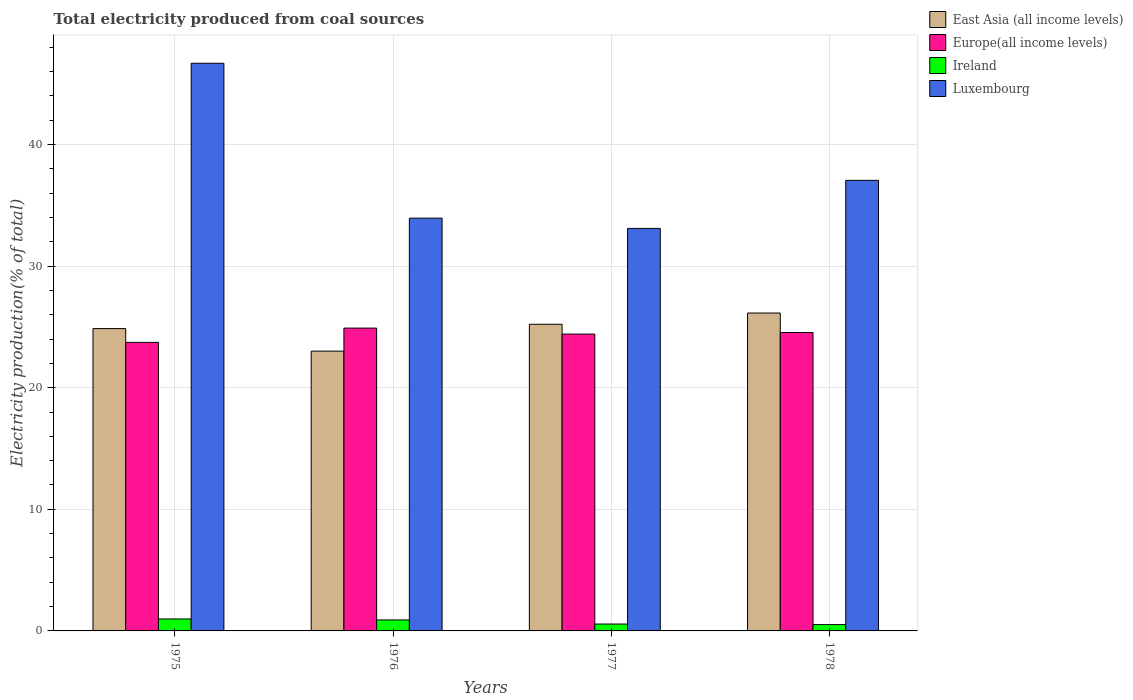Are the number of bars per tick equal to the number of legend labels?
Provide a short and direct response. Yes. Are the number of bars on each tick of the X-axis equal?
Your answer should be compact. Yes. How many bars are there on the 3rd tick from the left?
Offer a very short reply. 4. What is the label of the 4th group of bars from the left?
Give a very brief answer. 1978. In how many cases, is the number of bars for a given year not equal to the number of legend labels?
Your response must be concise. 0. What is the total electricity produced in Ireland in 1978?
Make the answer very short. 0.52. Across all years, what is the maximum total electricity produced in Luxembourg?
Give a very brief answer. 46.68. Across all years, what is the minimum total electricity produced in Europe(all income levels)?
Make the answer very short. 23.73. In which year was the total electricity produced in East Asia (all income levels) maximum?
Make the answer very short. 1978. In which year was the total electricity produced in Europe(all income levels) minimum?
Offer a very short reply. 1975. What is the total total electricity produced in East Asia (all income levels) in the graph?
Offer a very short reply. 99.23. What is the difference between the total electricity produced in East Asia (all income levels) in 1977 and that in 1978?
Offer a terse response. -0.92. What is the difference between the total electricity produced in Europe(all income levels) in 1975 and the total electricity produced in Ireland in 1978?
Make the answer very short. 23.21. What is the average total electricity produced in Europe(all income levels) per year?
Make the answer very short. 24.39. In the year 1977, what is the difference between the total electricity produced in East Asia (all income levels) and total electricity produced in Europe(all income levels)?
Give a very brief answer. 0.81. What is the ratio of the total electricity produced in Europe(all income levels) in 1975 to that in 1977?
Offer a very short reply. 0.97. Is the total electricity produced in Luxembourg in 1975 less than that in 1976?
Your response must be concise. No. Is the difference between the total electricity produced in East Asia (all income levels) in 1977 and 1978 greater than the difference between the total electricity produced in Europe(all income levels) in 1977 and 1978?
Ensure brevity in your answer.  No. What is the difference between the highest and the second highest total electricity produced in Luxembourg?
Your response must be concise. 9.63. What is the difference between the highest and the lowest total electricity produced in Ireland?
Your response must be concise. 0.47. Is the sum of the total electricity produced in Luxembourg in 1976 and 1978 greater than the maximum total electricity produced in East Asia (all income levels) across all years?
Your response must be concise. Yes. Is it the case that in every year, the sum of the total electricity produced in Europe(all income levels) and total electricity produced in Luxembourg is greater than the sum of total electricity produced in Ireland and total electricity produced in East Asia (all income levels)?
Provide a succinct answer. Yes. What does the 1st bar from the left in 1977 represents?
Give a very brief answer. East Asia (all income levels). What does the 3rd bar from the right in 1976 represents?
Make the answer very short. Europe(all income levels). Is it the case that in every year, the sum of the total electricity produced in Luxembourg and total electricity produced in Europe(all income levels) is greater than the total electricity produced in East Asia (all income levels)?
Your answer should be very brief. Yes. Are the values on the major ticks of Y-axis written in scientific E-notation?
Your response must be concise. No. How many legend labels are there?
Make the answer very short. 4. How are the legend labels stacked?
Offer a terse response. Vertical. What is the title of the graph?
Keep it short and to the point. Total electricity produced from coal sources. What is the label or title of the X-axis?
Offer a terse response. Years. What is the Electricity production(% of total) in East Asia (all income levels) in 1975?
Make the answer very short. 24.86. What is the Electricity production(% of total) of Europe(all income levels) in 1975?
Your response must be concise. 23.73. What is the Electricity production(% of total) in Ireland in 1975?
Offer a very short reply. 0.98. What is the Electricity production(% of total) in Luxembourg in 1975?
Your response must be concise. 46.68. What is the Electricity production(% of total) in East Asia (all income levels) in 1976?
Provide a succinct answer. 23.01. What is the Electricity production(% of total) in Europe(all income levels) in 1976?
Keep it short and to the point. 24.9. What is the Electricity production(% of total) of Ireland in 1976?
Provide a short and direct response. 0.9. What is the Electricity production(% of total) in Luxembourg in 1976?
Your response must be concise. 33.94. What is the Electricity production(% of total) in East Asia (all income levels) in 1977?
Ensure brevity in your answer.  25.22. What is the Electricity production(% of total) in Europe(all income levels) in 1977?
Provide a succinct answer. 24.41. What is the Electricity production(% of total) in Ireland in 1977?
Your answer should be compact. 0.57. What is the Electricity production(% of total) of Luxembourg in 1977?
Make the answer very short. 33.1. What is the Electricity production(% of total) of East Asia (all income levels) in 1978?
Your response must be concise. 26.14. What is the Electricity production(% of total) in Europe(all income levels) in 1978?
Ensure brevity in your answer.  24.54. What is the Electricity production(% of total) in Ireland in 1978?
Offer a very short reply. 0.52. What is the Electricity production(% of total) in Luxembourg in 1978?
Offer a very short reply. 37.05. Across all years, what is the maximum Electricity production(% of total) in East Asia (all income levels)?
Keep it short and to the point. 26.14. Across all years, what is the maximum Electricity production(% of total) of Europe(all income levels)?
Your answer should be very brief. 24.9. Across all years, what is the maximum Electricity production(% of total) of Ireland?
Your answer should be compact. 0.98. Across all years, what is the maximum Electricity production(% of total) in Luxembourg?
Provide a short and direct response. 46.68. Across all years, what is the minimum Electricity production(% of total) in East Asia (all income levels)?
Provide a succinct answer. 23.01. Across all years, what is the minimum Electricity production(% of total) of Europe(all income levels)?
Your answer should be compact. 23.73. Across all years, what is the minimum Electricity production(% of total) in Ireland?
Your answer should be compact. 0.52. Across all years, what is the minimum Electricity production(% of total) in Luxembourg?
Provide a short and direct response. 33.1. What is the total Electricity production(% of total) of East Asia (all income levels) in the graph?
Offer a terse response. 99.23. What is the total Electricity production(% of total) of Europe(all income levels) in the graph?
Provide a short and direct response. 97.57. What is the total Electricity production(% of total) in Ireland in the graph?
Give a very brief answer. 2.97. What is the total Electricity production(% of total) of Luxembourg in the graph?
Your answer should be compact. 150.77. What is the difference between the Electricity production(% of total) in East Asia (all income levels) in 1975 and that in 1976?
Offer a very short reply. 1.85. What is the difference between the Electricity production(% of total) of Europe(all income levels) in 1975 and that in 1976?
Offer a terse response. -1.18. What is the difference between the Electricity production(% of total) of Ireland in 1975 and that in 1976?
Provide a succinct answer. 0.08. What is the difference between the Electricity production(% of total) of Luxembourg in 1975 and that in 1976?
Your answer should be very brief. 12.74. What is the difference between the Electricity production(% of total) in East Asia (all income levels) in 1975 and that in 1977?
Provide a succinct answer. -0.36. What is the difference between the Electricity production(% of total) in Europe(all income levels) in 1975 and that in 1977?
Ensure brevity in your answer.  -0.68. What is the difference between the Electricity production(% of total) in Ireland in 1975 and that in 1977?
Keep it short and to the point. 0.42. What is the difference between the Electricity production(% of total) of Luxembourg in 1975 and that in 1977?
Provide a succinct answer. 13.58. What is the difference between the Electricity production(% of total) in East Asia (all income levels) in 1975 and that in 1978?
Your answer should be compact. -1.28. What is the difference between the Electricity production(% of total) of Europe(all income levels) in 1975 and that in 1978?
Ensure brevity in your answer.  -0.81. What is the difference between the Electricity production(% of total) of Ireland in 1975 and that in 1978?
Provide a succinct answer. 0.47. What is the difference between the Electricity production(% of total) of Luxembourg in 1975 and that in 1978?
Your answer should be compact. 9.63. What is the difference between the Electricity production(% of total) of East Asia (all income levels) in 1976 and that in 1977?
Give a very brief answer. -2.21. What is the difference between the Electricity production(% of total) of Europe(all income levels) in 1976 and that in 1977?
Offer a very short reply. 0.49. What is the difference between the Electricity production(% of total) in Ireland in 1976 and that in 1977?
Provide a succinct answer. 0.34. What is the difference between the Electricity production(% of total) in Luxembourg in 1976 and that in 1977?
Your answer should be very brief. 0.84. What is the difference between the Electricity production(% of total) of East Asia (all income levels) in 1976 and that in 1978?
Your answer should be compact. -3.13. What is the difference between the Electricity production(% of total) of Europe(all income levels) in 1976 and that in 1978?
Offer a terse response. 0.37. What is the difference between the Electricity production(% of total) in Ireland in 1976 and that in 1978?
Your answer should be compact. 0.38. What is the difference between the Electricity production(% of total) of Luxembourg in 1976 and that in 1978?
Provide a short and direct response. -3.11. What is the difference between the Electricity production(% of total) in East Asia (all income levels) in 1977 and that in 1978?
Your answer should be very brief. -0.92. What is the difference between the Electricity production(% of total) of Europe(all income levels) in 1977 and that in 1978?
Your response must be concise. -0.13. What is the difference between the Electricity production(% of total) in Ireland in 1977 and that in 1978?
Your response must be concise. 0.05. What is the difference between the Electricity production(% of total) of Luxembourg in 1977 and that in 1978?
Offer a terse response. -3.95. What is the difference between the Electricity production(% of total) in East Asia (all income levels) in 1975 and the Electricity production(% of total) in Europe(all income levels) in 1976?
Offer a very short reply. -0.04. What is the difference between the Electricity production(% of total) in East Asia (all income levels) in 1975 and the Electricity production(% of total) in Ireland in 1976?
Your response must be concise. 23.96. What is the difference between the Electricity production(% of total) in East Asia (all income levels) in 1975 and the Electricity production(% of total) in Luxembourg in 1976?
Your response must be concise. -9.08. What is the difference between the Electricity production(% of total) in Europe(all income levels) in 1975 and the Electricity production(% of total) in Ireland in 1976?
Provide a succinct answer. 22.82. What is the difference between the Electricity production(% of total) of Europe(all income levels) in 1975 and the Electricity production(% of total) of Luxembourg in 1976?
Provide a succinct answer. -10.22. What is the difference between the Electricity production(% of total) in Ireland in 1975 and the Electricity production(% of total) in Luxembourg in 1976?
Offer a terse response. -32.96. What is the difference between the Electricity production(% of total) of East Asia (all income levels) in 1975 and the Electricity production(% of total) of Europe(all income levels) in 1977?
Give a very brief answer. 0.45. What is the difference between the Electricity production(% of total) in East Asia (all income levels) in 1975 and the Electricity production(% of total) in Ireland in 1977?
Offer a terse response. 24.3. What is the difference between the Electricity production(% of total) in East Asia (all income levels) in 1975 and the Electricity production(% of total) in Luxembourg in 1977?
Offer a terse response. -8.24. What is the difference between the Electricity production(% of total) of Europe(all income levels) in 1975 and the Electricity production(% of total) of Ireland in 1977?
Ensure brevity in your answer.  23.16. What is the difference between the Electricity production(% of total) of Europe(all income levels) in 1975 and the Electricity production(% of total) of Luxembourg in 1977?
Your answer should be very brief. -9.37. What is the difference between the Electricity production(% of total) of Ireland in 1975 and the Electricity production(% of total) of Luxembourg in 1977?
Your answer should be very brief. -32.11. What is the difference between the Electricity production(% of total) in East Asia (all income levels) in 1975 and the Electricity production(% of total) in Europe(all income levels) in 1978?
Make the answer very short. 0.33. What is the difference between the Electricity production(% of total) in East Asia (all income levels) in 1975 and the Electricity production(% of total) in Ireland in 1978?
Your response must be concise. 24.34. What is the difference between the Electricity production(% of total) of East Asia (all income levels) in 1975 and the Electricity production(% of total) of Luxembourg in 1978?
Offer a terse response. -12.19. What is the difference between the Electricity production(% of total) of Europe(all income levels) in 1975 and the Electricity production(% of total) of Ireland in 1978?
Keep it short and to the point. 23.21. What is the difference between the Electricity production(% of total) of Europe(all income levels) in 1975 and the Electricity production(% of total) of Luxembourg in 1978?
Provide a succinct answer. -13.32. What is the difference between the Electricity production(% of total) in Ireland in 1975 and the Electricity production(% of total) in Luxembourg in 1978?
Your response must be concise. -36.07. What is the difference between the Electricity production(% of total) of East Asia (all income levels) in 1976 and the Electricity production(% of total) of Europe(all income levels) in 1977?
Keep it short and to the point. -1.4. What is the difference between the Electricity production(% of total) in East Asia (all income levels) in 1976 and the Electricity production(% of total) in Ireland in 1977?
Keep it short and to the point. 22.44. What is the difference between the Electricity production(% of total) in East Asia (all income levels) in 1976 and the Electricity production(% of total) in Luxembourg in 1977?
Keep it short and to the point. -10.09. What is the difference between the Electricity production(% of total) in Europe(all income levels) in 1976 and the Electricity production(% of total) in Ireland in 1977?
Ensure brevity in your answer.  24.34. What is the difference between the Electricity production(% of total) in Europe(all income levels) in 1976 and the Electricity production(% of total) in Luxembourg in 1977?
Make the answer very short. -8.2. What is the difference between the Electricity production(% of total) in Ireland in 1976 and the Electricity production(% of total) in Luxembourg in 1977?
Offer a very short reply. -32.2. What is the difference between the Electricity production(% of total) of East Asia (all income levels) in 1976 and the Electricity production(% of total) of Europe(all income levels) in 1978?
Make the answer very short. -1.53. What is the difference between the Electricity production(% of total) in East Asia (all income levels) in 1976 and the Electricity production(% of total) in Ireland in 1978?
Provide a short and direct response. 22.49. What is the difference between the Electricity production(% of total) of East Asia (all income levels) in 1976 and the Electricity production(% of total) of Luxembourg in 1978?
Your answer should be compact. -14.04. What is the difference between the Electricity production(% of total) in Europe(all income levels) in 1976 and the Electricity production(% of total) in Ireland in 1978?
Keep it short and to the point. 24.38. What is the difference between the Electricity production(% of total) in Europe(all income levels) in 1976 and the Electricity production(% of total) in Luxembourg in 1978?
Ensure brevity in your answer.  -12.15. What is the difference between the Electricity production(% of total) in Ireland in 1976 and the Electricity production(% of total) in Luxembourg in 1978?
Offer a terse response. -36.15. What is the difference between the Electricity production(% of total) of East Asia (all income levels) in 1977 and the Electricity production(% of total) of Europe(all income levels) in 1978?
Offer a terse response. 0.68. What is the difference between the Electricity production(% of total) in East Asia (all income levels) in 1977 and the Electricity production(% of total) in Ireland in 1978?
Ensure brevity in your answer.  24.7. What is the difference between the Electricity production(% of total) of East Asia (all income levels) in 1977 and the Electricity production(% of total) of Luxembourg in 1978?
Provide a succinct answer. -11.83. What is the difference between the Electricity production(% of total) of Europe(all income levels) in 1977 and the Electricity production(% of total) of Ireland in 1978?
Make the answer very short. 23.89. What is the difference between the Electricity production(% of total) in Europe(all income levels) in 1977 and the Electricity production(% of total) in Luxembourg in 1978?
Give a very brief answer. -12.64. What is the difference between the Electricity production(% of total) in Ireland in 1977 and the Electricity production(% of total) in Luxembourg in 1978?
Make the answer very short. -36.48. What is the average Electricity production(% of total) of East Asia (all income levels) per year?
Keep it short and to the point. 24.81. What is the average Electricity production(% of total) in Europe(all income levels) per year?
Make the answer very short. 24.39. What is the average Electricity production(% of total) of Ireland per year?
Offer a terse response. 0.74. What is the average Electricity production(% of total) of Luxembourg per year?
Your answer should be compact. 37.69. In the year 1975, what is the difference between the Electricity production(% of total) in East Asia (all income levels) and Electricity production(% of total) in Europe(all income levels)?
Provide a short and direct response. 1.14. In the year 1975, what is the difference between the Electricity production(% of total) in East Asia (all income levels) and Electricity production(% of total) in Ireland?
Make the answer very short. 23.88. In the year 1975, what is the difference between the Electricity production(% of total) in East Asia (all income levels) and Electricity production(% of total) in Luxembourg?
Offer a terse response. -21.82. In the year 1975, what is the difference between the Electricity production(% of total) in Europe(all income levels) and Electricity production(% of total) in Ireland?
Ensure brevity in your answer.  22.74. In the year 1975, what is the difference between the Electricity production(% of total) of Europe(all income levels) and Electricity production(% of total) of Luxembourg?
Provide a succinct answer. -22.95. In the year 1975, what is the difference between the Electricity production(% of total) in Ireland and Electricity production(% of total) in Luxembourg?
Offer a very short reply. -45.7. In the year 1976, what is the difference between the Electricity production(% of total) of East Asia (all income levels) and Electricity production(% of total) of Europe(all income levels)?
Offer a terse response. -1.89. In the year 1976, what is the difference between the Electricity production(% of total) of East Asia (all income levels) and Electricity production(% of total) of Ireland?
Keep it short and to the point. 22.11. In the year 1976, what is the difference between the Electricity production(% of total) in East Asia (all income levels) and Electricity production(% of total) in Luxembourg?
Your response must be concise. -10.93. In the year 1976, what is the difference between the Electricity production(% of total) in Europe(all income levels) and Electricity production(% of total) in Ireland?
Offer a very short reply. 24. In the year 1976, what is the difference between the Electricity production(% of total) of Europe(all income levels) and Electricity production(% of total) of Luxembourg?
Provide a short and direct response. -9.04. In the year 1976, what is the difference between the Electricity production(% of total) of Ireland and Electricity production(% of total) of Luxembourg?
Keep it short and to the point. -33.04. In the year 1977, what is the difference between the Electricity production(% of total) in East Asia (all income levels) and Electricity production(% of total) in Europe(all income levels)?
Keep it short and to the point. 0.81. In the year 1977, what is the difference between the Electricity production(% of total) in East Asia (all income levels) and Electricity production(% of total) in Ireland?
Provide a succinct answer. 24.65. In the year 1977, what is the difference between the Electricity production(% of total) of East Asia (all income levels) and Electricity production(% of total) of Luxembourg?
Give a very brief answer. -7.88. In the year 1977, what is the difference between the Electricity production(% of total) in Europe(all income levels) and Electricity production(% of total) in Ireland?
Your answer should be very brief. 23.84. In the year 1977, what is the difference between the Electricity production(% of total) of Europe(all income levels) and Electricity production(% of total) of Luxembourg?
Your answer should be very brief. -8.69. In the year 1977, what is the difference between the Electricity production(% of total) in Ireland and Electricity production(% of total) in Luxembourg?
Give a very brief answer. -32.53. In the year 1978, what is the difference between the Electricity production(% of total) in East Asia (all income levels) and Electricity production(% of total) in Europe(all income levels)?
Make the answer very short. 1.61. In the year 1978, what is the difference between the Electricity production(% of total) in East Asia (all income levels) and Electricity production(% of total) in Ireland?
Your response must be concise. 25.62. In the year 1978, what is the difference between the Electricity production(% of total) of East Asia (all income levels) and Electricity production(% of total) of Luxembourg?
Provide a succinct answer. -10.91. In the year 1978, what is the difference between the Electricity production(% of total) of Europe(all income levels) and Electricity production(% of total) of Ireland?
Provide a short and direct response. 24.02. In the year 1978, what is the difference between the Electricity production(% of total) of Europe(all income levels) and Electricity production(% of total) of Luxembourg?
Offer a terse response. -12.51. In the year 1978, what is the difference between the Electricity production(% of total) of Ireland and Electricity production(% of total) of Luxembourg?
Your response must be concise. -36.53. What is the ratio of the Electricity production(% of total) of East Asia (all income levels) in 1975 to that in 1976?
Provide a succinct answer. 1.08. What is the ratio of the Electricity production(% of total) of Europe(all income levels) in 1975 to that in 1976?
Your response must be concise. 0.95. What is the ratio of the Electricity production(% of total) of Ireland in 1975 to that in 1976?
Provide a short and direct response. 1.09. What is the ratio of the Electricity production(% of total) of Luxembourg in 1975 to that in 1976?
Provide a succinct answer. 1.38. What is the ratio of the Electricity production(% of total) of East Asia (all income levels) in 1975 to that in 1977?
Your response must be concise. 0.99. What is the ratio of the Electricity production(% of total) of Europe(all income levels) in 1975 to that in 1977?
Offer a terse response. 0.97. What is the ratio of the Electricity production(% of total) of Ireland in 1975 to that in 1977?
Provide a succinct answer. 1.74. What is the ratio of the Electricity production(% of total) in Luxembourg in 1975 to that in 1977?
Your answer should be compact. 1.41. What is the ratio of the Electricity production(% of total) of East Asia (all income levels) in 1975 to that in 1978?
Keep it short and to the point. 0.95. What is the ratio of the Electricity production(% of total) in Europe(all income levels) in 1975 to that in 1978?
Your response must be concise. 0.97. What is the ratio of the Electricity production(% of total) of Ireland in 1975 to that in 1978?
Your response must be concise. 1.9. What is the ratio of the Electricity production(% of total) of Luxembourg in 1975 to that in 1978?
Keep it short and to the point. 1.26. What is the ratio of the Electricity production(% of total) in East Asia (all income levels) in 1976 to that in 1977?
Make the answer very short. 0.91. What is the ratio of the Electricity production(% of total) in Europe(all income levels) in 1976 to that in 1977?
Provide a short and direct response. 1.02. What is the ratio of the Electricity production(% of total) in Ireland in 1976 to that in 1977?
Your answer should be very brief. 1.6. What is the ratio of the Electricity production(% of total) in Luxembourg in 1976 to that in 1977?
Keep it short and to the point. 1.03. What is the ratio of the Electricity production(% of total) in East Asia (all income levels) in 1976 to that in 1978?
Provide a short and direct response. 0.88. What is the ratio of the Electricity production(% of total) in Europe(all income levels) in 1976 to that in 1978?
Your answer should be compact. 1.01. What is the ratio of the Electricity production(% of total) of Ireland in 1976 to that in 1978?
Ensure brevity in your answer.  1.74. What is the ratio of the Electricity production(% of total) in Luxembourg in 1976 to that in 1978?
Provide a short and direct response. 0.92. What is the ratio of the Electricity production(% of total) of East Asia (all income levels) in 1977 to that in 1978?
Provide a short and direct response. 0.96. What is the ratio of the Electricity production(% of total) of Europe(all income levels) in 1977 to that in 1978?
Offer a very short reply. 0.99. What is the ratio of the Electricity production(% of total) in Ireland in 1977 to that in 1978?
Your answer should be very brief. 1.09. What is the ratio of the Electricity production(% of total) of Luxembourg in 1977 to that in 1978?
Ensure brevity in your answer.  0.89. What is the difference between the highest and the second highest Electricity production(% of total) in East Asia (all income levels)?
Keep it short and to the point. 0.92. What is the difference between the highest and the second highest Electricity production(% of total) of Europe(all income levels)?
Your answer should be compact. 0.37. What is the difference between the highest and the second highest Electricity production(% of total) of Ireland?
Provide a short and direct response. 0.08. What is the difference between the highest and the second highest Electricity production(% of total) of Luxembourg?
Your answer should be very brief. 9.63. What is the difference between the highest and the lowest Electricity production(% of total) in East Asia (all income levels)?
Give a very brief answer. 3.13. What is the difference between the highest and the lowest Electricity production(% of total) of Europe(all income levels)?
Offer a terse response. 1.18. What is the difference between the highest and the lowest Electricity production(% of total) in Ireland?
Ensure brevity in your answer.  0.47. What is the difference between the highest and the lowest Electricity production(% of total) in Luxembourg?
Your response must be concise. 13.58. 